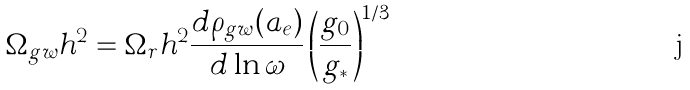Convert formula to latex. <formula><loc_0><loc_0><loc_500><loc_500>\Omega _ { g w } h ^ { 2 } = \Omega _ { r } h ^ { 2 } \frac { d \rho _ { g w } ( a _ { e } ) } { d \ln \omega } \left ( \frac { g _ { 0 } } { g _ { * } } \right ) ^ { 1 / 3 }</formula> 